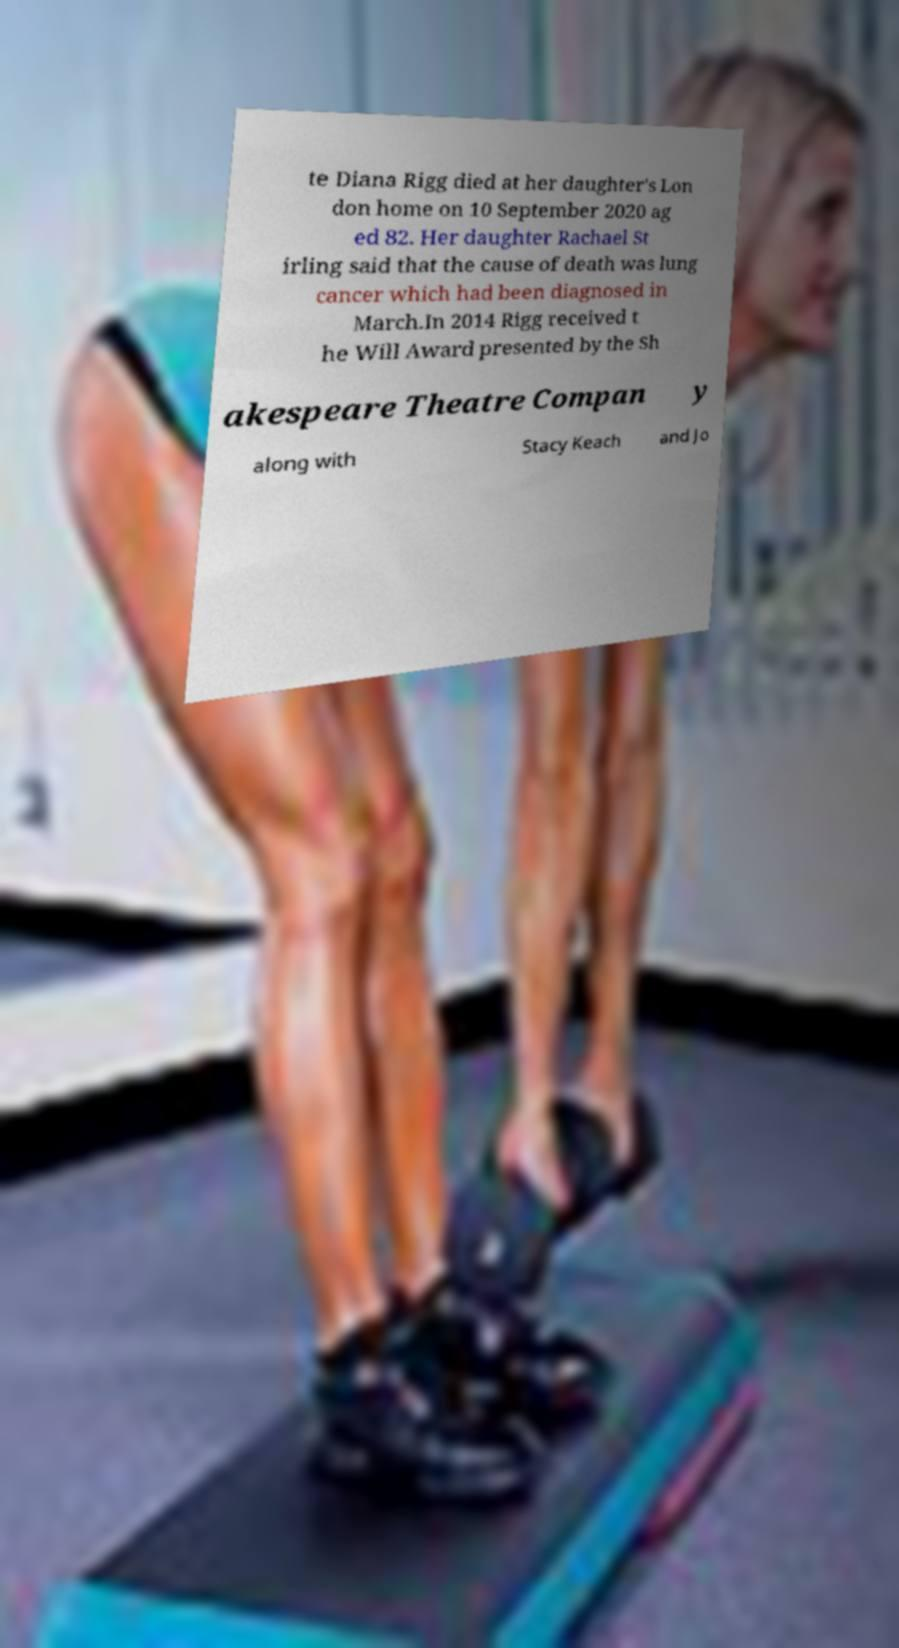Please identify and transcribe the text found in this image. te Diana Rigg died at her daughter's Lon don home on 10 September 2020 ag ed 82. Her daughter Rachael St irling said that the cause of death was lung cancer which had been diagnosed in March.In 2014 Rigg received t he Will Award presented by the Sh akespeare Theatre Compan y along with Stacy Keach and Jo 